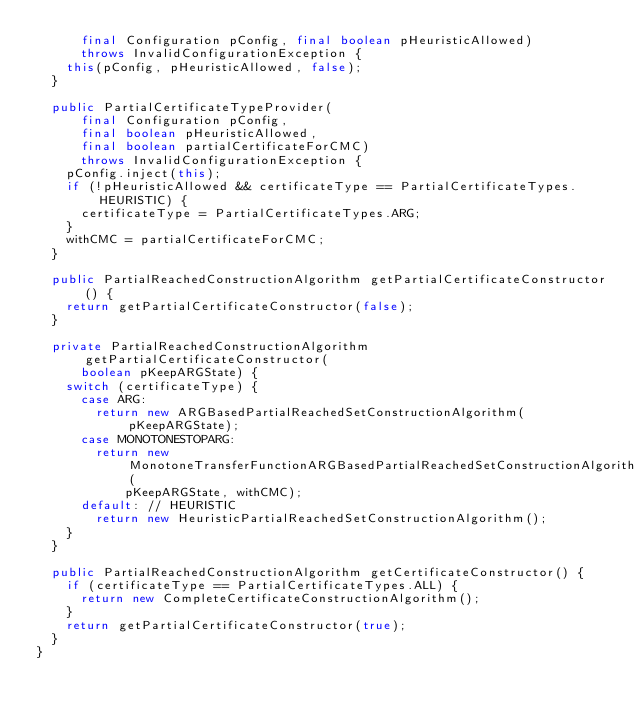Convert code to text. <code><loc_0><loc_0><loc_500><loc_500><_Java_>      final Configuration pConfig, final boolean pHeuristicAllowed)
      throws InvalidConfigurationException {
    this(pConfig, pHeuristicAllowed, false);
  }

  public PartialCertificateTypeProvider(
      final Configuration pConfig,
      final boolean pHeuristicAllowed,
      final boolean partialCertificateForCMC)
      throws InvalidConfigurationException {
    pConfig.inject(this);
    if (!pHeuristicAllowed && certificateType == PartialCertificateTypes.HEURISTIC) {
      certificateType = PartialCertificateTypes.ARG;
    }
    withCMC = partialCertificateForCMC;
  }

  public PartialReachedConstructionAlgorithm getPartialCertificateConstructor() {
    return getPartialCertificateConstructor(false);
  }

  private PartialReachedConstructionAlgorithm getPartialCertificateConstructor(
      boolean pKeepARGState) {
    switch (certificateType) {
      case ARG:
        return new ARGBasedPartialReachedSetConstructionAlgorithm(pKeepARGState);
      case MONOTONESTOPARG:
        return new MonotoneTransferFunctionARGBasedPartialReachedSetConstructionAlgorithm(
            pKeepARGState, withCMC);
      default: // HEURISTIC
        return new HeuristicPartialReachedSetConstructionAlgorithm();
    }
  }

  public PartialReachedConstructionAlgorithm getCertificateConstructor() {
    if (certificateType == PartialCertificateTypes.ALL) {
      return new CompleteCertificateConstructionAlgorithm();
    }
    return getPartialCertificateConstructor(true);
  }
}
</code> 